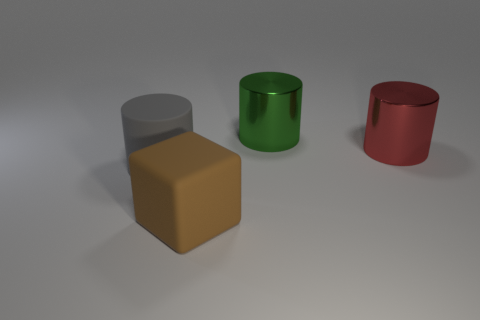How many objects are there in the image, and can you describe their shapes? There are four objects in the image. Starting from the left, there's a cylindrical object with a flat top, a cube-shaped object, another cylindrical object, and lastly, a cylindrical object with a slightly beveled top edge. They each have distinct geometrical shapes.  Are the objects casting any shadows, and if so, what does that tell us about the light source? Yes, each object is casting a shadow. The shadows extend to the right of the objects, suggesting that the light source is coming from the left side, likely above the objects judging by the shadow's lengths and angles. 